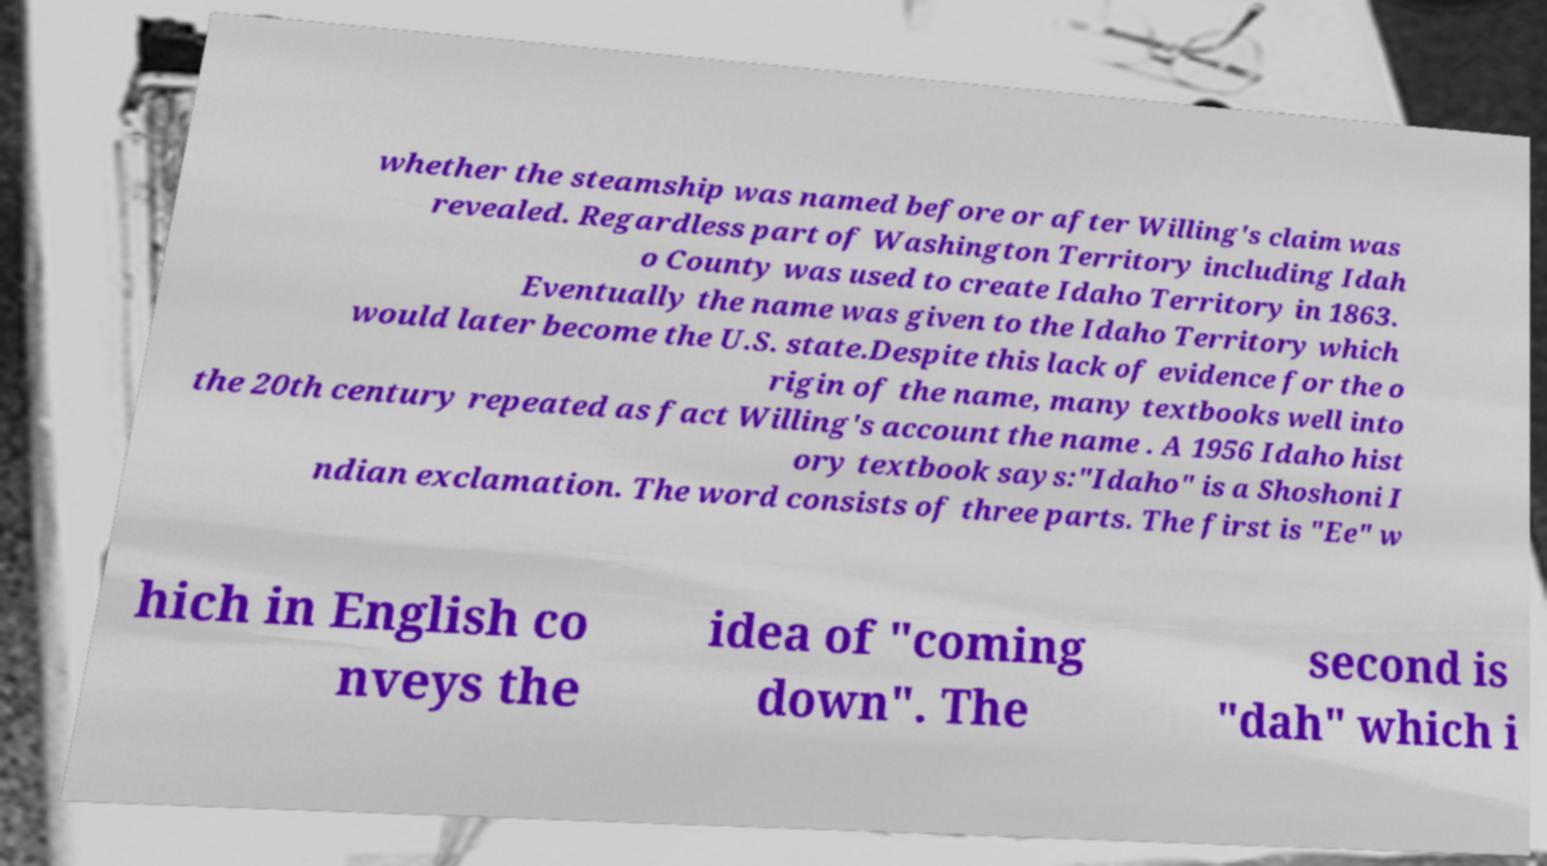I need the written content from this picture converted into text. Can you do that? whether the steamship was named before or after Willing's claim was revealed. Regardless part of Washington Territory including Idah o County was used to create Idaho Territory in 1863. Eventually the name was given to the Idaho Territory which would later become the U.S. state.Despite this lack of evidence for the o rigin of the name, many textbooks well into the 20th century repeated as fact Willing's account the name . A 1956 Idaho hist ory textbook says:"Idaho" is a Shoshoni I ndian exclamation. The word consists of three parts. The first is "Ee" w hich in English co nveys the idea of "coming down". The second is "dah" which i 